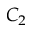Convert formula to latex. <formula><loc_0><loc_0><loc_500><loc_500>C _ { 2 }</formula> 